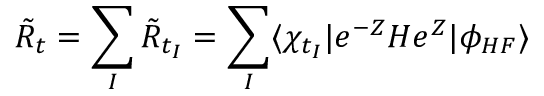Convert formula to latex. <formula><loc_0><loc_0><loc_500><loc_500>\tilde { R } _ { t } = \sum _ { I } \tilde { R } _ { t _ { I } } = \sum _ { I } \langle \chi _ { t _ { I } } | e ^ { - Z } H e ^ { Z } | \phi _ { H F } \rangle</formula> 